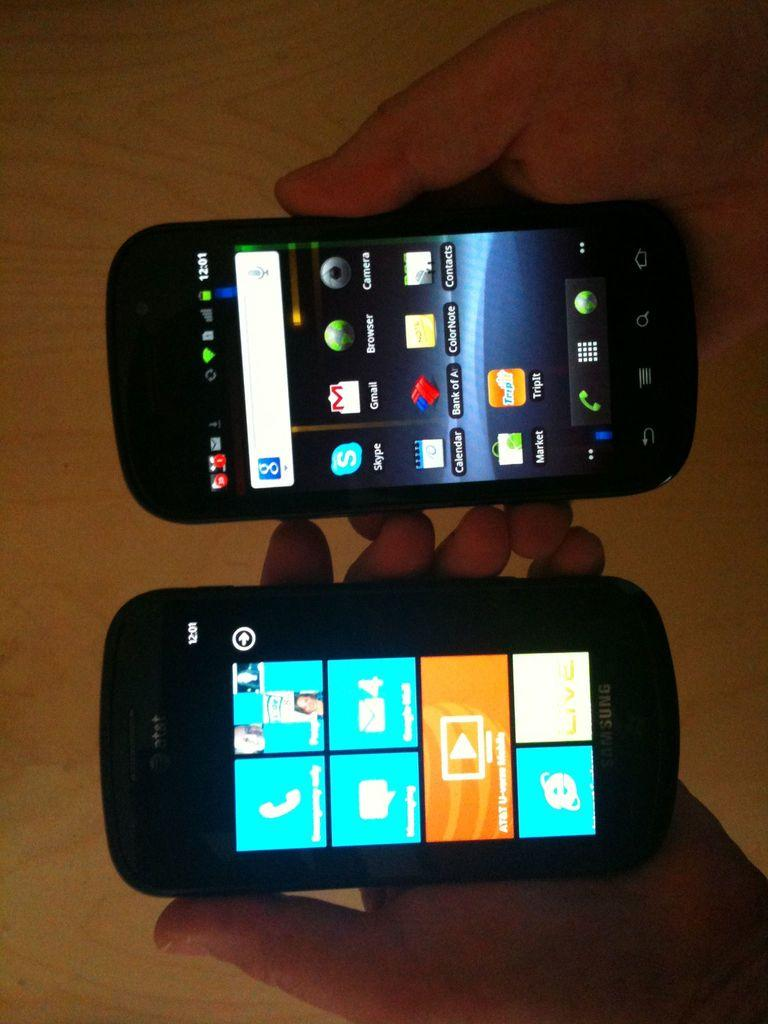<image>
Describe the image concisely. Two phones next to each other, one of an AT&T smartphone with a collage of apples to use such as the telephone and internet explorer. 